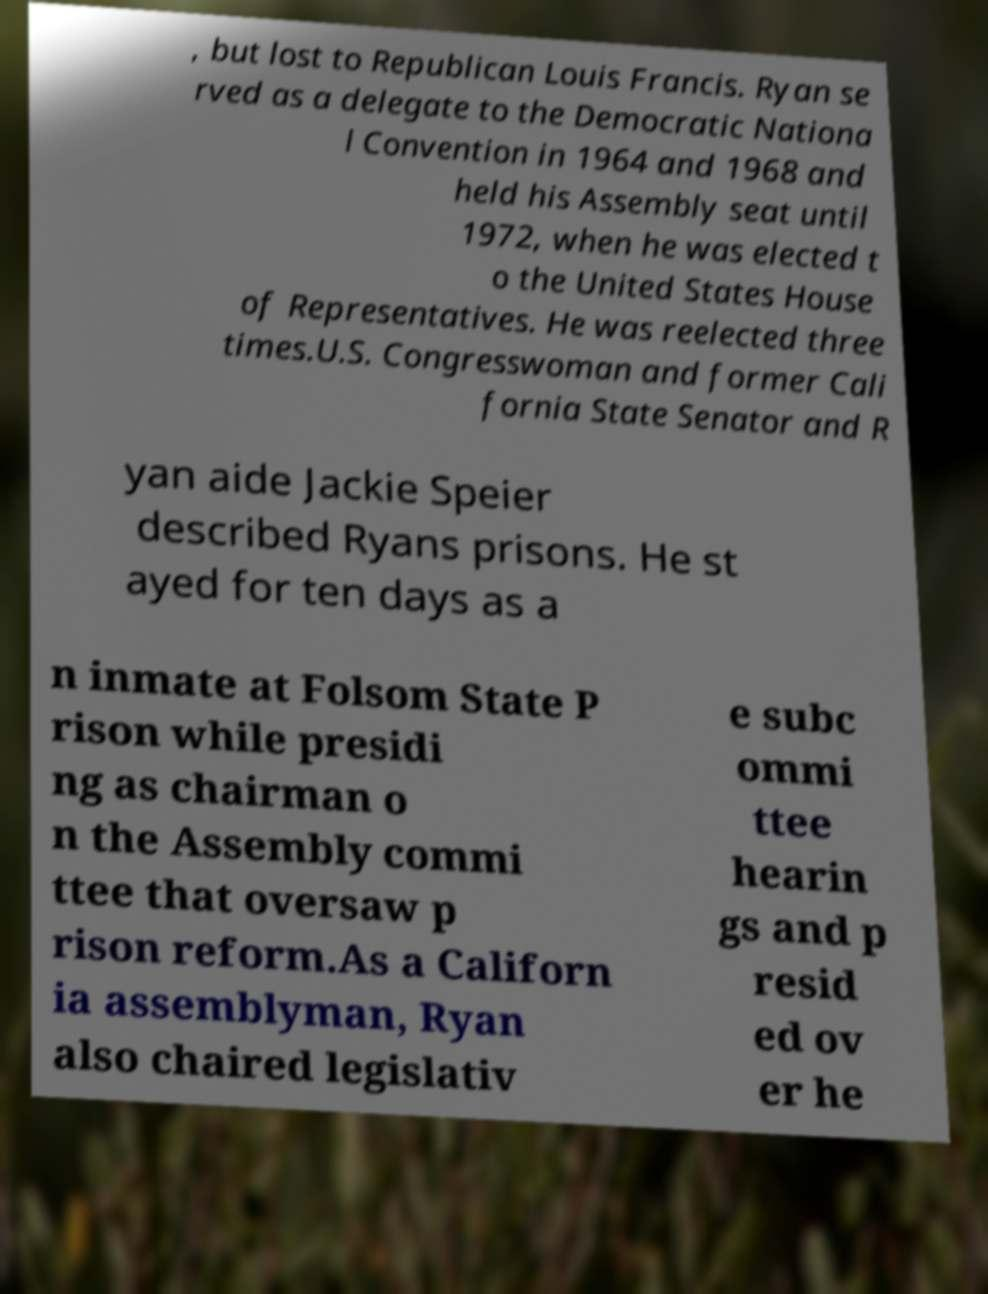Please read and relay the text visible in this image. What does it say? , but lost to Republican Louis Francis. Ryan se rved as a delegate to the Democratic Nationa l Convention in 1964 and 1968 and held his Assembly seat until 1972, when he was elected t o the United States House of Representatives. He was reelected three times.U.S. Congresswoman and former Cali fornia State Senator and R yan aide Jackie Speier described Ryans prisons. He st ayed for ten days as a n inmate at Folsom State P rison while presidi ng as chairman o n the Assembly commi ttee that oversaw p rison reform.As a Californ ia assemblyman, Ryan also chaired legislativ e subc ommi ttee hearin gs and p resid ed ov er he 